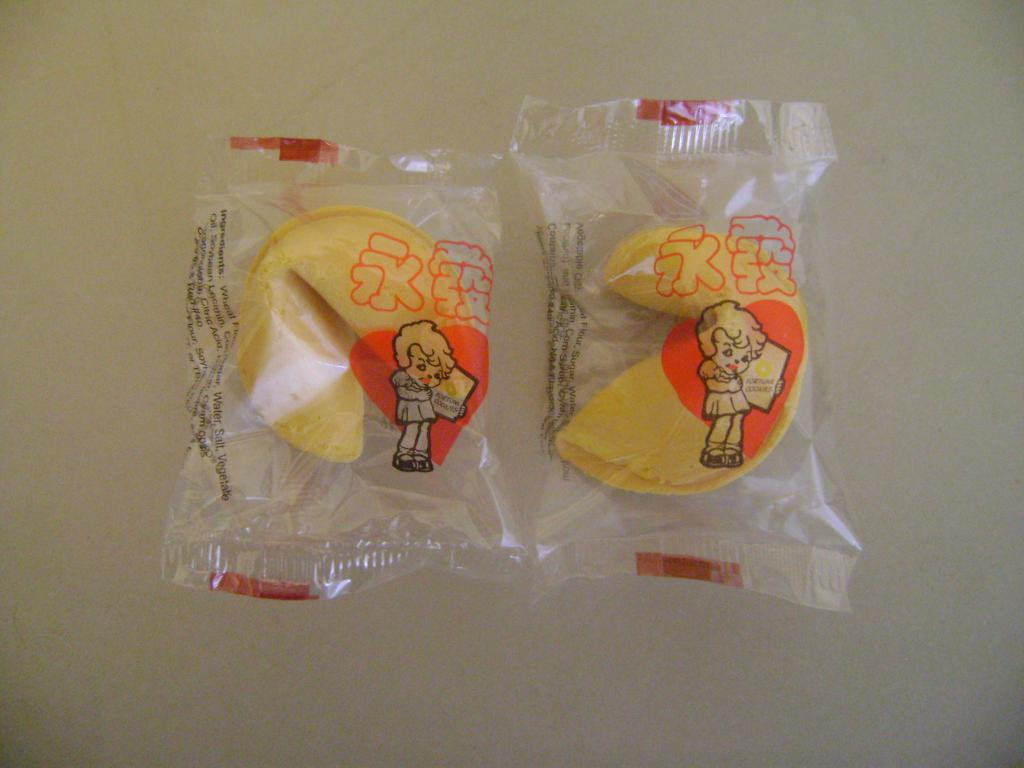What type of food is shown in the image? The food is in packets, but the specific type of food is not mentioned in the facts. How are the food items packaged? The food is in packets. Can you describe the person in the image? The facts only mention that there is a person in the image, but no specific details about the person are provided. What information is printed on the packet cover? Text is printed on the packet cover. What historical event is depicted on the packet cover? There is no information about any historical event depicted on the packet cover, as the facts only mention that text is printed on it. What degree does the person in the image hold? There is no information about the person's education or qualifications, as the facts only mention that there is a person in the image. 